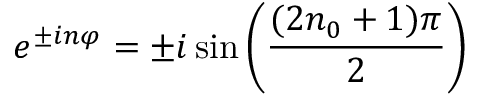<formula> <loc_0><loc_0><loc_500><loc_500>e ^ { \pm i n \varphi } = \pm i \sin \left ( \frac { ( 2 n _ { 0 } + 1 ) \pi } { 2 } \right )</formula> 